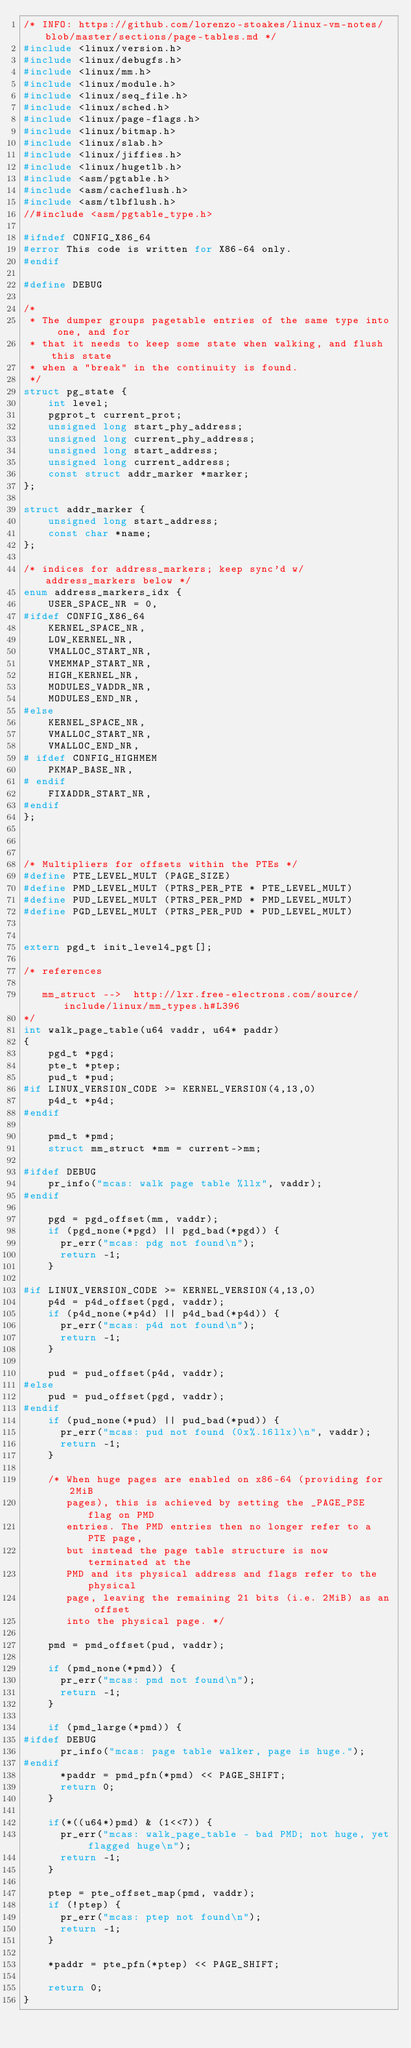<code> <loc_0><loc_0><loc_500><loc_500><_C_>/* INFO: https://github.com/lorenzo-stoakes/linux-vm-notes/blob/master/sections/page-tables.md */
#include <linux/version.h>
#include <linux/debugfs.h>
#include <linux/mm.h>
#include <linux/module.h>
#include <linux/seq_file.h>
#include <linux/sched.h>
#include <linux/page-flags.h>
#include <linux/bitmap.h>
#include <linux/slab.h>
#include <linux/jiffies.h>
#include <linux/hugetlb.h>
#include <asm/pgtable.h>
#include <asm/cacheflush.h>
#include <asm/tlbflush.h>
//#include <asm/pgtable_type.h>

#ifndef CONFIG_X86_64
#error This code is written for X86-64 only.
#endif

#define DEBUG

/*
 * The dumper groups pagetable entries of the same type into one, and for
 * that it needs to keep some state when walking, and flush this state
 * when a "break" in the continuity is found.
 */
struct pg_state {
	int level;
	pgprot_t current_prot;
	unsigned long start_phy_address;
	unsigned long current_phy_address;
	unsigned long start_address;
	unsigned long current_address;
	const struct addr_marker *marker;
};

struct addr_marker {
	unsigned long start_address;
	const char *name;
};

/* indices for address_markers; keep sync'd w/ address_markers below */
enum address_markers_idx {
	USER_SPACE_NR = 0,
#ifdef CONFIG_X86_64
	KERNEL_SPACE_NR,
	LOW_KERNEL_NR,
	VMALLOC_START_NR,
	VMEMMAP_START_NR,
	HIGH_KERNEL_NR,
	MODULES_VADDR_NR,
	MODULES_END_NR,
#else
	KERNEL_SPACE_NR,
	VMALLOC_START_NR,
	VMALLOC_END_NR,
# ifdef CONFIG_HIGHMEM
	PKMAP_BASE_NR,
# endif
	FIXADDR_START_NR,
#endif
};



/* Multipliers for offsets within the PTEs */
#define PTE_LEVEL_MULT (PAGE_SIZE)
#define PMD_LEVEL_MULT (PTRS_PER_PTE * PTE_LEVEL_MULT)
#define PUD_LEVEL_MULT (PTRS_PER_PMD * PMD_LEVEL_MULT)
#define PGD_LEVEL_MULT (PTRS_PER_PUD * PUD_LEVEL_MULT)


extern pgd_t init_level4_pgt[];

/* references

   mm_struct -->  http://lxr.free-electrons.com/source/include/linux/mm_types.h#L396
*/
int walk_page_table(u64 vaddr, u64* paddr)
{
    pgd_t *pgd;
    pte_t *ptep;
    pud_t *pud;
#if LINUX_VERSION_CODE >= KERNEL_VERSION(4,13,0)
    p4d_t *p4d;
#endif
    
    pmd_t *pmd;
    struct mm_struct *mm = current->mm;

#ifdef DEBUG
    pr_info("mcas: walk page table %llx", vaddr);
#endif
    
    pgd = pgd_offset(mm, vaddr);
    if (pgd_none(*pgd) || pgd_bad(*pgd)) {
      pr_err("mcas: pdg not found\n");
      return -1;
    }    

#if LINUX_VERSION_CODE >= KERNEL_VERSION(4,13,0)    
    p4d = p4d_offset(pgd, vaddr);    
    if (p4d_none(*p4d) || p4d_bad(*p4d)) {
      pr_err("mcas: p4d not found\n");
      return -1;
    }
    
    pud = pud_offset(p4d, vaddr);
#else
    pud = pud_offset(pgd, vaddr);
#endif
    if (pud_none(*pud) || pud_bad(*pud)) {
      pr_err("mcas: pud not found (0x%.16llx)\n", vaddr);
      return -1;
    }
    
    /* When huge pages are enabled on x86-64 (providing for 2MiB
       pages), this is achieved by setting the _PAGE_PSE flag on PMD
       entries. The PMD entries then no longer refer to a PTE page,
       but instead the page table structure is now terminated at the
       PMD and its physical address and flags refer to the physical
       page, leaving the remaining 21 bits (i.e. 2MiB) as an offset
       into the physical page. */
    
    pmd = pmd_offset(pud, vaddr);

    if (pmd_none(*pmd)) {
      pr_err("mcas: pmd not found\n");
      return -1;
    }

    if (pmd_large(*pmd)) {
#ifdef DEBUG
      pr_info("mcas: page table walker, page is huge.");
#endif
      *paddr = pmd_pfn(*pmd) << PAGE_SHIFT;
      return 0;
    }

    if(*((u64*)pmd) & (1<<7)) {
      pr_err("mcas: walk_page_table - bad PMD; not huge, yet flagged huge\n");
      return -1;
    }

    ptep = pte_offset_map(pmd, vaddr);
    if (!ptep) {
      pr_err("mcas: ptep not found\n");
      return -1;
    }

    *paddr = pte_pfn(*ptep) << PAGE_SHIFT;

    return 0;
}

</code> 